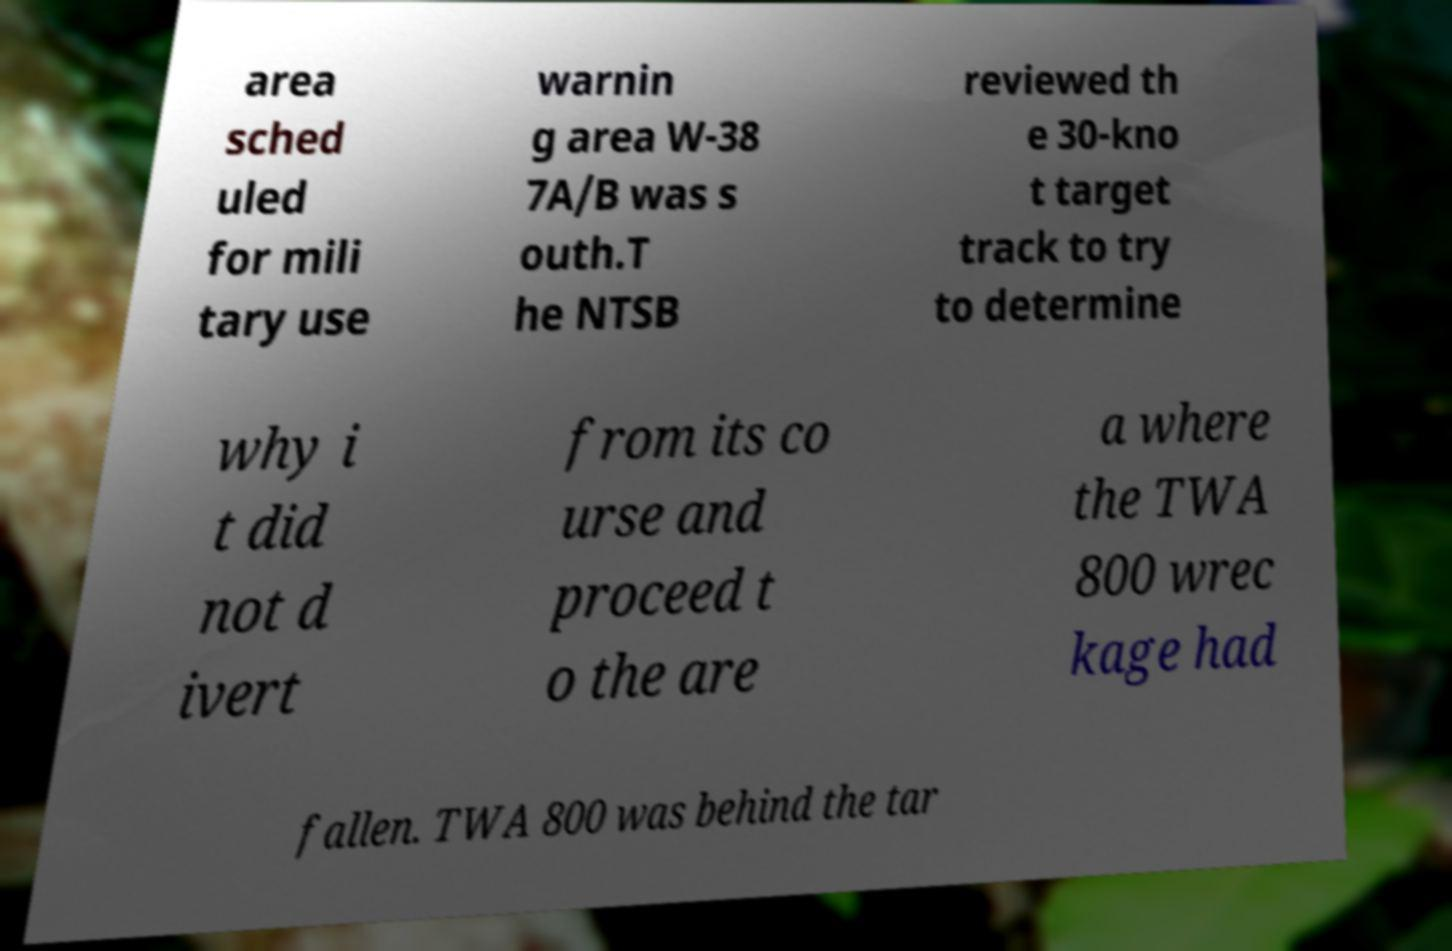For documentation purposes, I need the text within this image transcribed. Could you provide that? area sched uled for mili tary use warnin g area W-38 7A/B was s outh.T he NTSB reviewed th e 30-kno t target track to try to determine why i t did not d ivert from its co urse and proceed t o the are a where the TWA 800 wrec kage had fallen. TWA 800 was behind the tar 